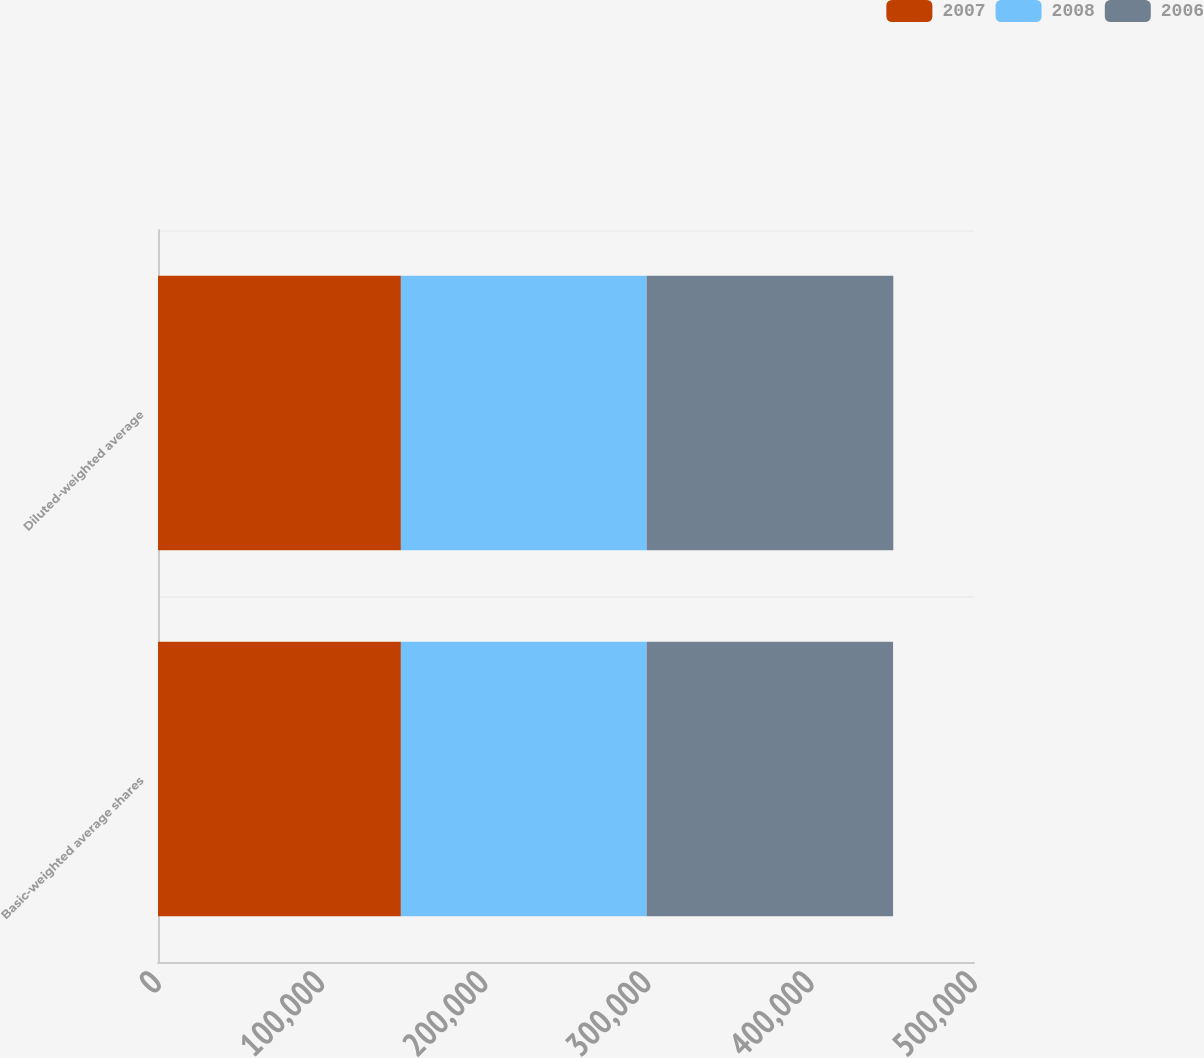<chart> <loc_0><loc_0><loc_500><loc_500><stacked_bar_chart><ecel><fcel>Basic-weighted average shares<fcel>Diluted-weighted average<nl><fcel>2007<fcel>148831<fcel>148831<nl><fcel>2008<fcel>150555<fcel>150555<nl><fcel>2006<fcel>151034<fcel>151165<nl></chart> 